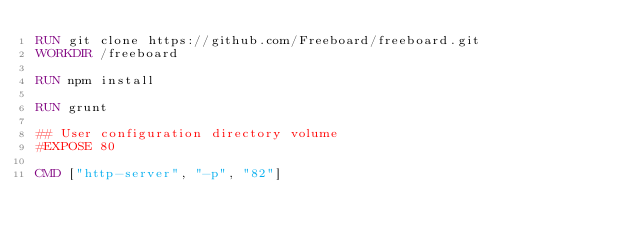<code> <loc_0><loc_0><loc_500><loc_500><_Dockerfile_>RUN git clone https://github.com/Freeboard/freeboard.git
WORKDIR /freeboard

RUN npm install

RUN grunt

## User configuration directory volume
#EXPOSE 80

CMD ["http-server", "-p", "82"]</code> 